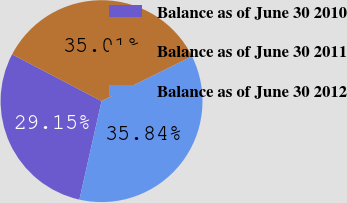Convert chart. <chart><loc_0><loc_0><loc_500><loc_500><pie_chart><fcel>Balance as of June 30 2010<fcel>Balance as of June 30 2011<fcel>Balance as of June 30 2012<nl><fcel>29.15%<fcel>35.01%<fcel>35.84%<nl></chart> 